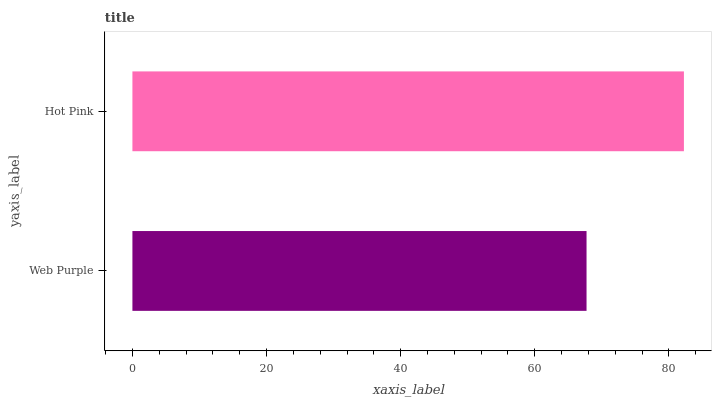Is Web Purple the minimum?
Answer yes or no. Yes. Is Hot Pink the maximum?
Answer yes or no. Yes. Is Hot Pink the minimum?
Answer yes or no. No. Is Hot Pink greater than Web Purple?
Answer yes or no. Yes. Is Web Purple less than Hot Pink?
Answer yes or no. Yes. Is Web Purple greater than Hot Pink?
Answer yes or no. No. Is Hot Pink less than Web Purple?
Answer yes or no. No. Is Hot Pink the high median?
Answer yes or no. Yes. Is Web Purple the low median?
Answer yes or no. Yes. Is Web Purple the high median?
Answer yes or no. No. Is Hot Pink the low median?
Answer yes or no. No. 